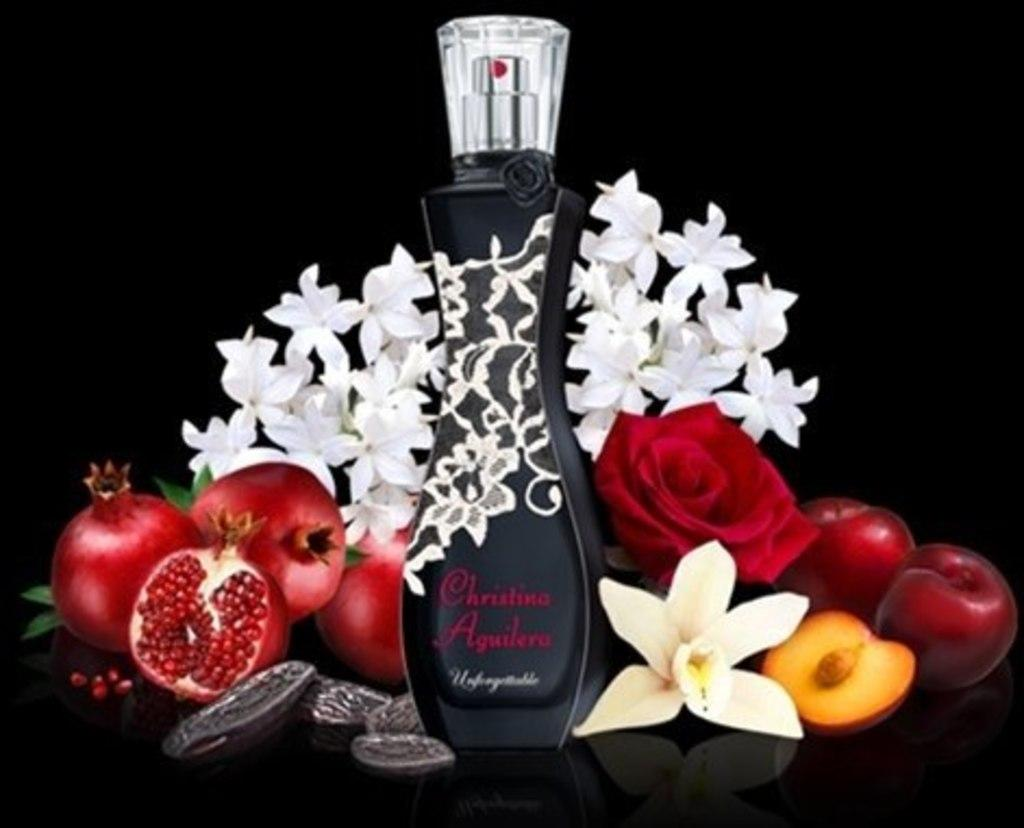<image>
Provide a brief description of the given image. The black bottle of Christina Aguilera perfume is surrounded by pomegranates, roses, and other flowers and fruits. 